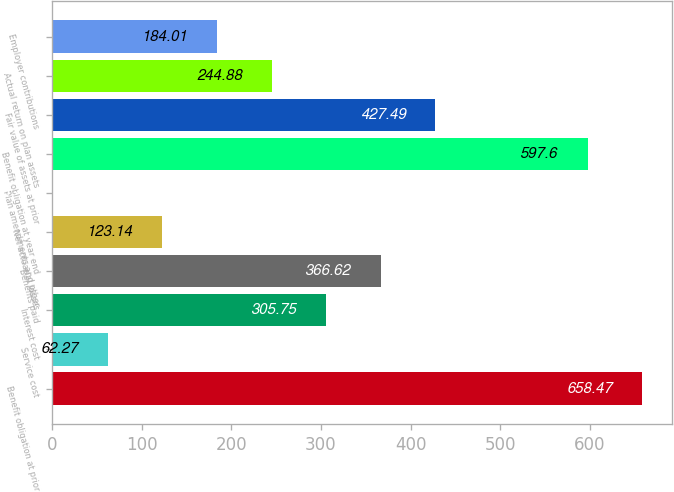<chart> <loc_0><loc_0><loc_500><loc_500><bar_chart><fcel>Benefit obligation at prior<fcel>Service cost<fcel>Interest cost<fcel>Benefits paid<fcel>Net actuarial losses<fcel>Plan amendments and other<fcel>Benefit obligation at year end<fcel>Fair value of assets at prior<fcel>Actual return on plan assets<fcel>Employer contributions<nl><fcel>658.47<fcel>62.27<fcel>305.75<fcel>366.62<fcel>123.14<fcel>1.4<fcel>597.6<fcel>427.49<fcel>244.88<fcel>184.01<nl></chart> 